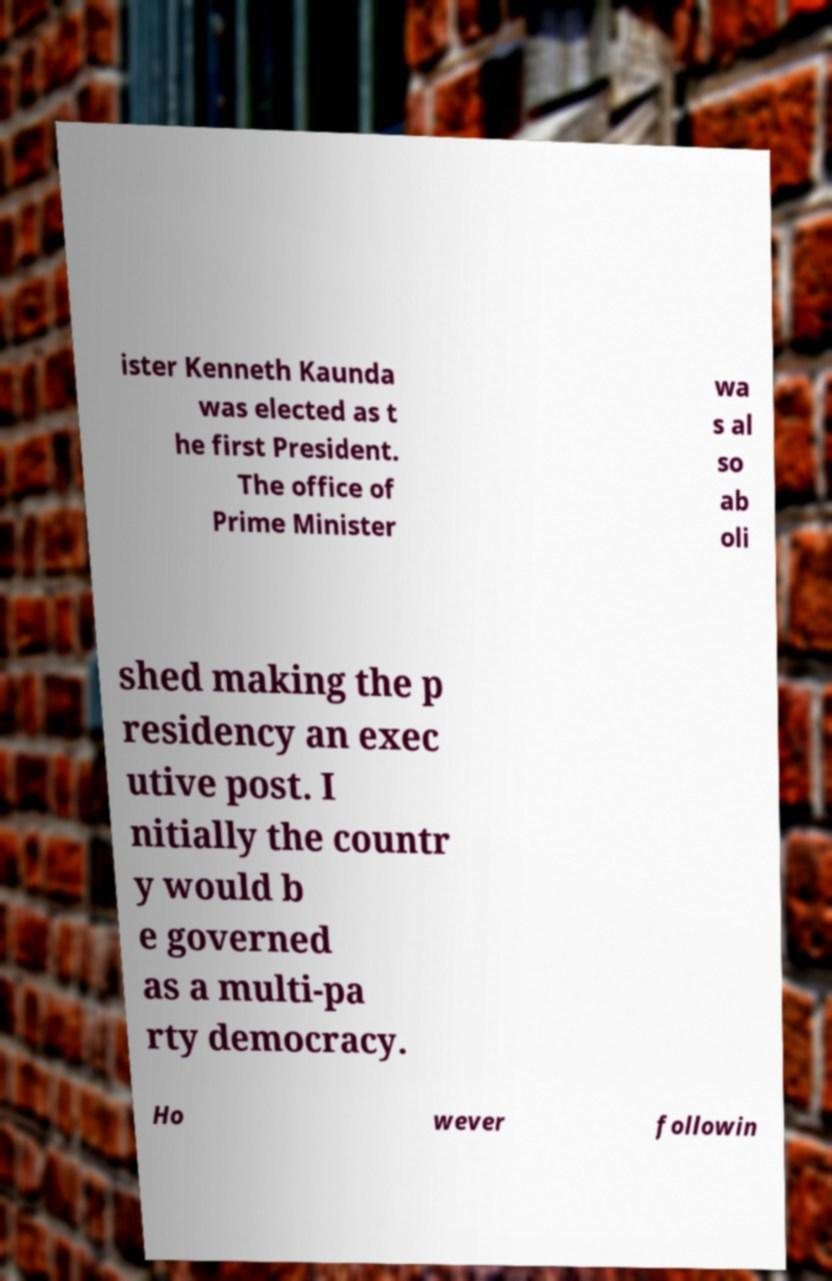For documentation purposes, I need the text within this image transcribed. Could you provide that? ister Kenneth Kaunda was elected as t he first President. The office of Prime Minister wa s al so ab oli shed making the p residency an exec utive post. I nitially the countr y would b e governed as a multi-pa rty democracy. Ho wever followin 